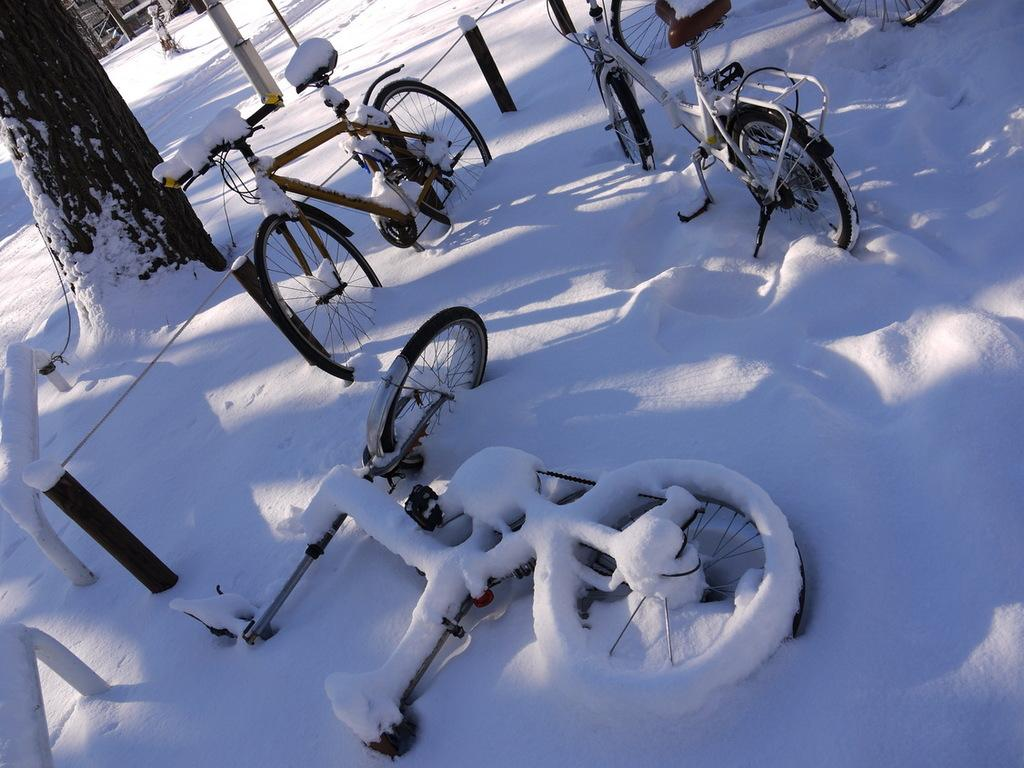What type of vehicles are in the image? There are bicycles in the image. What is the surface on which the bicycles are located? The bicycles are on the snow. How is the snow affecting the appearance of the bicycles? The bicycles are partially covered with snow. What natural element can be seen in the image? There is a tree trunk in the image. What man-made structure is visible in the image? There is a road in the image. Where is the dock located in the image? There is no dock present in the image. What type of corn can be seen growing near the bicycles? There is no corn present in the image. 